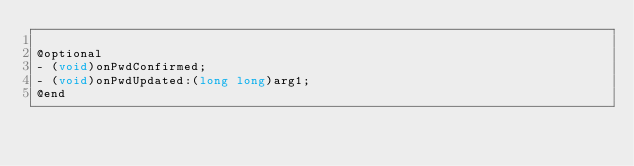Convert code to text. <code><loc_0><loc_0><loc_500><loc_500><_C_>
@optional
- (void)onPwdConfirmed;
- (void)onPwdUpdated:(long long)arg1;
@end

</code> 